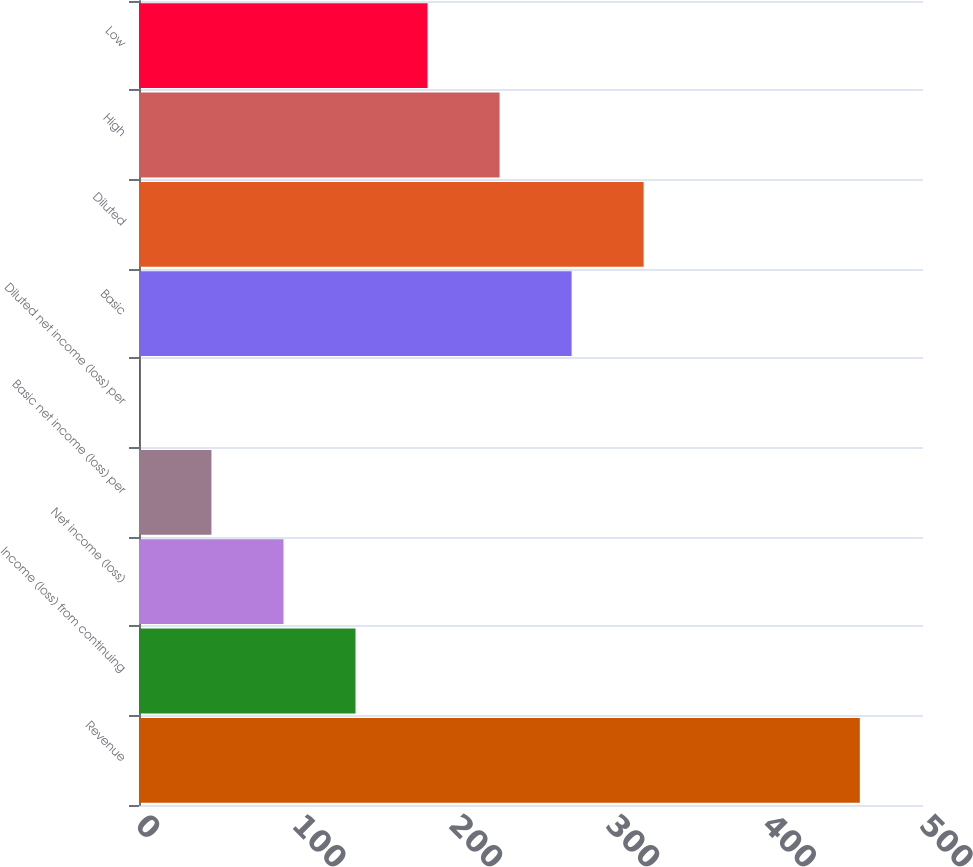Convert chart. <chart><loc_0><loc_0><loc_500><loc_500><bar_chart><fcel>Revenue<fcel>Income (loss) from continuing<fcel>Net income (loss)<fcel>Basic net income (loss) per<fcel>Diluted net income (loss) per<fcel>Basic<fcel>Diluted<fcel>High<fcel>Low<nl><fcel>459.7<fcel>138.08<fcel>92.14<fcel>46.2<fcel>0.26<fcel>275.9<fcel>321.84<fcel>229.96<fcel>184.02<nl></chart> 